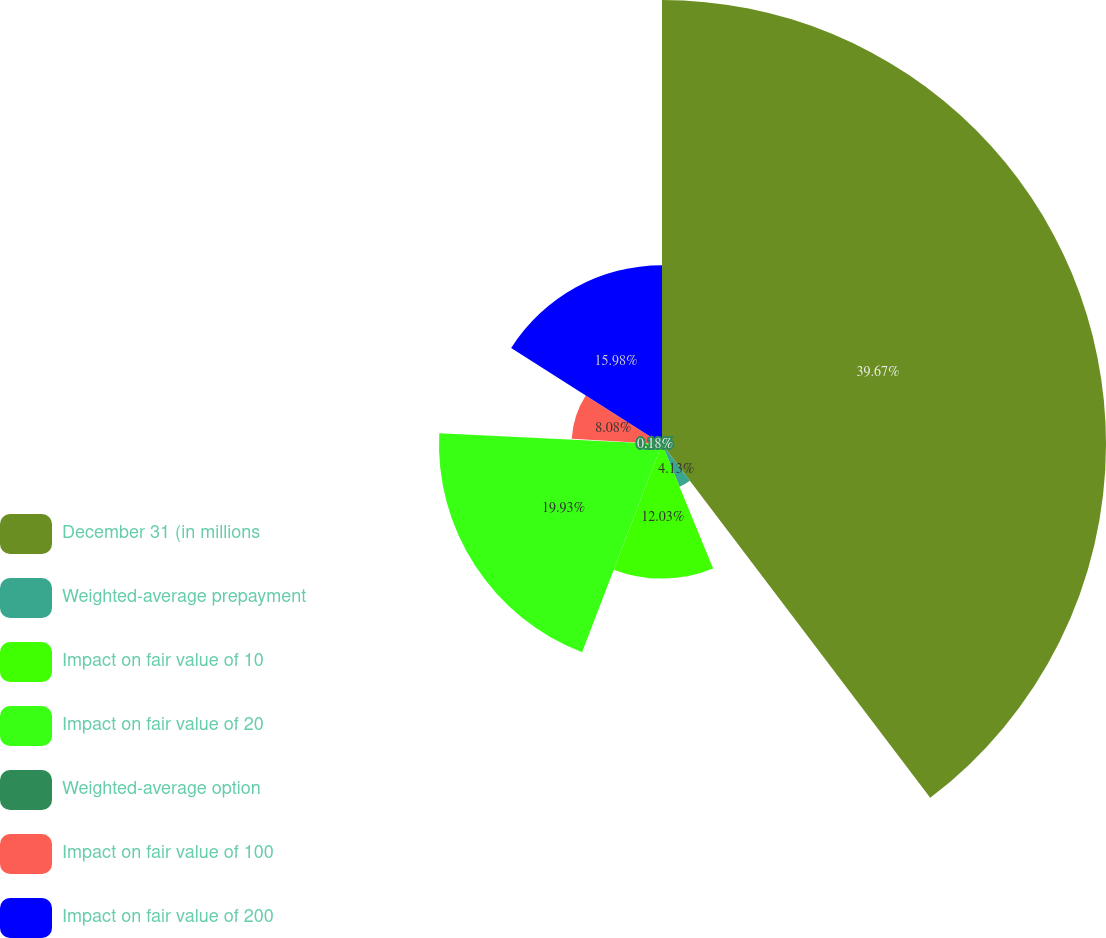Convert chart. <chart><loc_0><loc_0><loc_500><loc_500><pie_chart><fcel>December 31 (in millions<fcel>Weighted-average prepayment<fcel>Impact on fair value of 10<fcel>Impact on fair value of 20<fcel>Weighted-average option<fcel>Impact on fair value of 100<fcel>Impact on fair value of 200<nl><fcel>39.68%<fcel>4.13%<fcel>12.03%<fcel>19.93%<fcel>0.18%<fcel>8.08%<fcel>15.98%<nl></chart> 